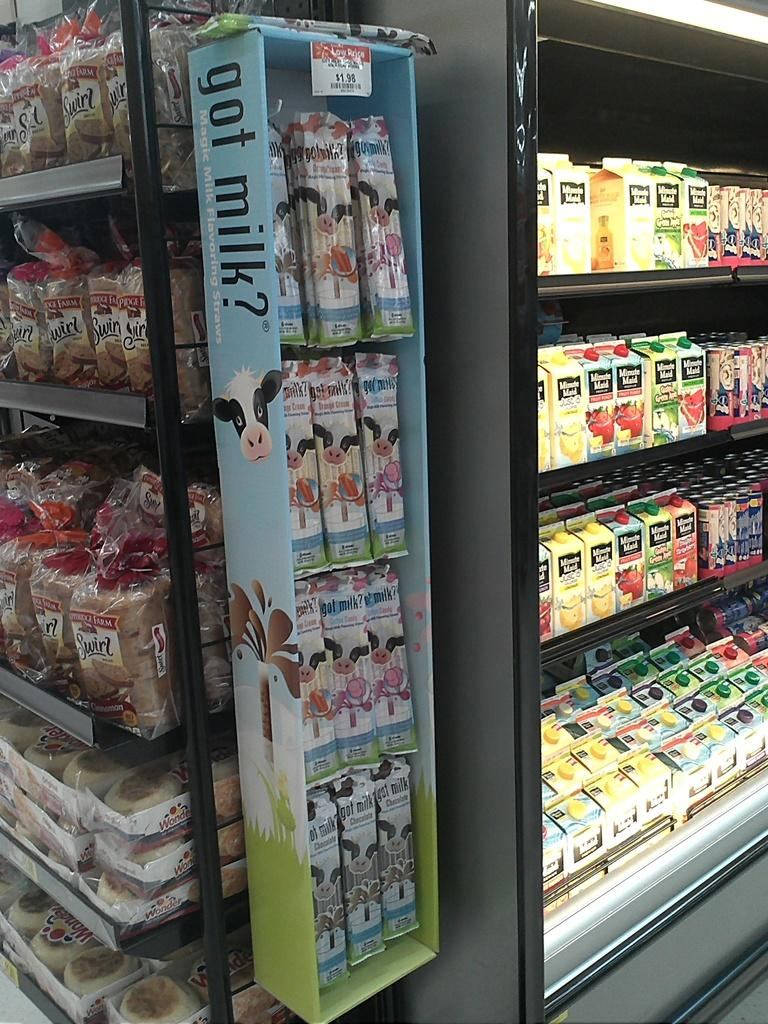<image>
Present a compact description of the photo's key features. A got milk display is on the endcap of the bread section of a grocery store and by juices. 